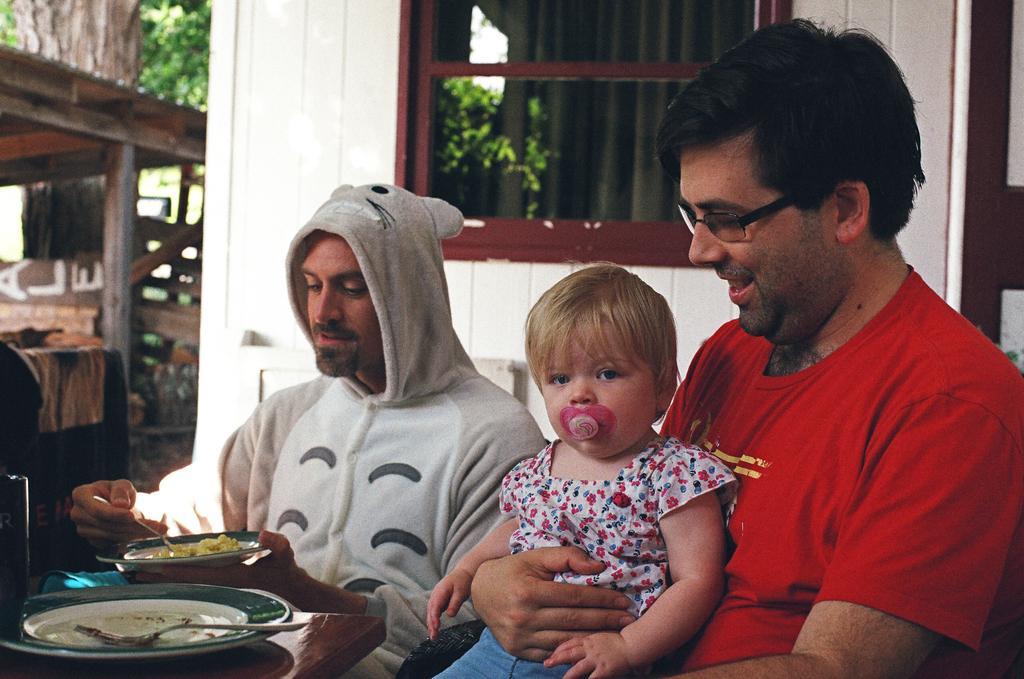Please provide a concise description of this image. There is a person wearing specs is holding a baby. And a person wearing a jacket is holding a plate and food item on it. In front of them there is a table. On that there is a plate with fork. In the background there is a building with window. Also there are trees and a wooden building in the background. 